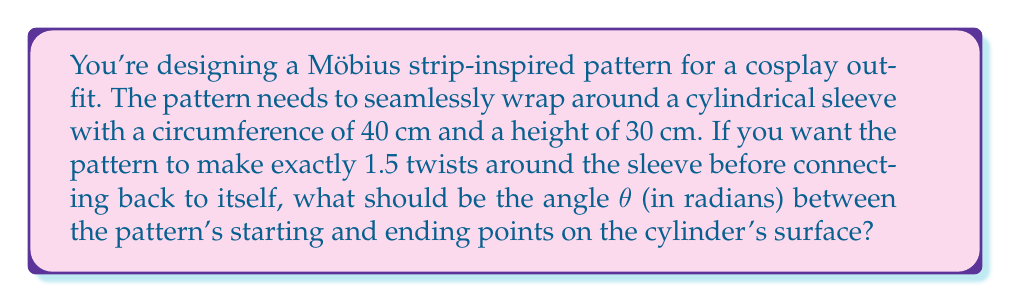What is the answer to this math problem? To solve this problem, we need to consider the topology of a Möbius strip and how it relates to the surface of a cylinder:

1) First, let's visualize the cylinder unrolled into a flat rectangle. The circumference (40 cm) becomes the width, and the height (30 cm) remains the same.

2) A Möbius strip with 1.5 twists is equivalent to a line that starts at one corner of this rectangle and ends at the opposite corner on the same edge after wrapping around 1.5 times.

3) The angle $\theta$ we're looking for is the angle this line makes with the horizontal axis of the cylinder.

4) We can calculate this using the arctangent function:

   $$\theta = \arctan(\frac{\text{height}}{\text{width}})$$

5) However, we need to account for the 1.5 twists. This means our "effective width" is 1.5 times the circumference:

   $$\text{Effective width} = 1.5 \times 40 \text{ cm} = 60 \text{ cm}$$

6) Now we can plug these values into our arctangent formula:

   $$\theta = \arctan(\frac{30 \text{ cm}}{60 \text{ cm}})$$

7) Simplifying:

   $$\theta = \arctan(0.5)$$

8) This gives us our final answer in radians.
Answer: $$\theta = \arctan(0.5) \approx 0.4636 \text{ radians}$$ 